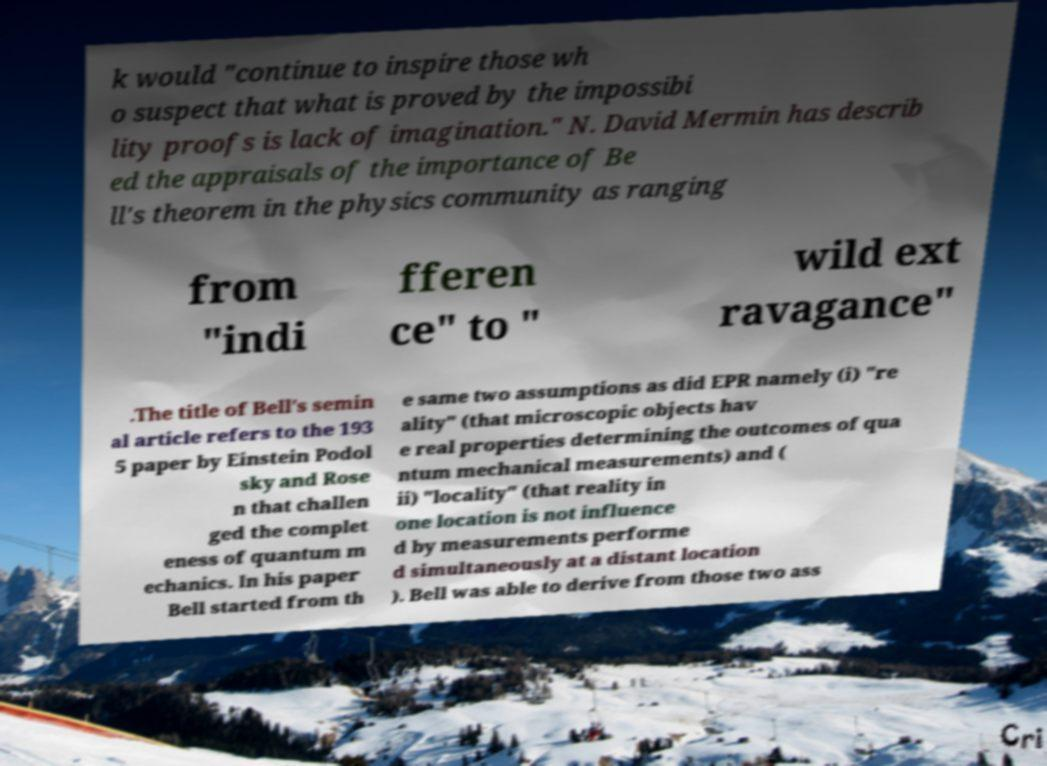Please identify and transcribe the text found in this image. k would "continue to inspire those wh o suspect that what is proved by the impossibi lity proofs is lack of imagination." N. David Mermin has describ ed the appraisals of the importance of Be ll's theorem in the physics community as ranging from "indi fferen ce" to " wild ext ravagance" .The title of Bell's semin al article refers to the 193 5 paper by Einstein Podol sky and Rose n that challen ged the complet eness of quantum m echanics. In his paper Bell started from th e same two assumptions as did EPR namely (i) "re ality" (that microscopic objects hav e real properties determining the outcomes of qua ntum mechanical measurements) and ( ii) "locality" (that reality in one location is not influence d by measurements performe d simultaneously at a distant location ). Bell was able to derive from those two ass 